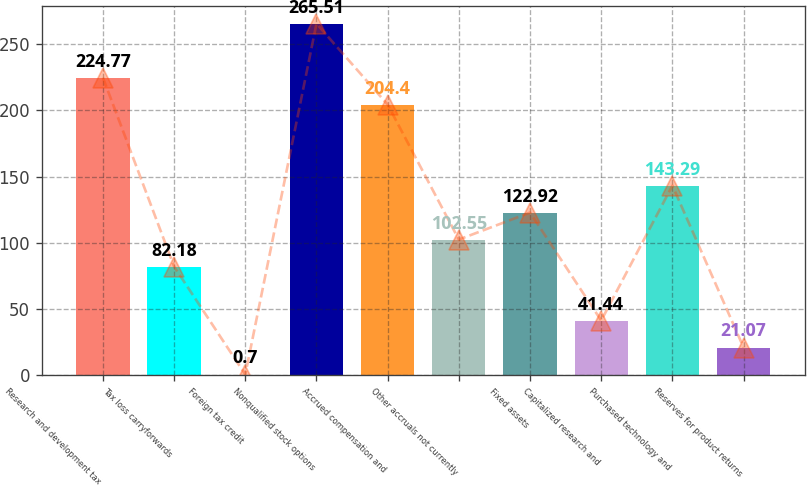Convert chart to OTSL. <chart><loc_0><loc_0><loc_500><loc_500><bar_chart><fcel>Research and development tax<fcel>Tax loss carryforwards<fcel>Foreign tax credit<fcel>Nonqualified stock options<fcel>Accrued compensation and<fcel>Other accruals not currently<fcel>Fixed assets<fcel>Capitalized research and<fcel>Purchased technology and<fcel>Reserves for product returns<nl><fcel>224.77<fcel>82.18<fcel>0.7<fcel>265.51<fcel>204.4<fcel>102.55<fcel>122.92<fcel>41.44<fcel>143.29<fcel>21.07<nl></chart> 